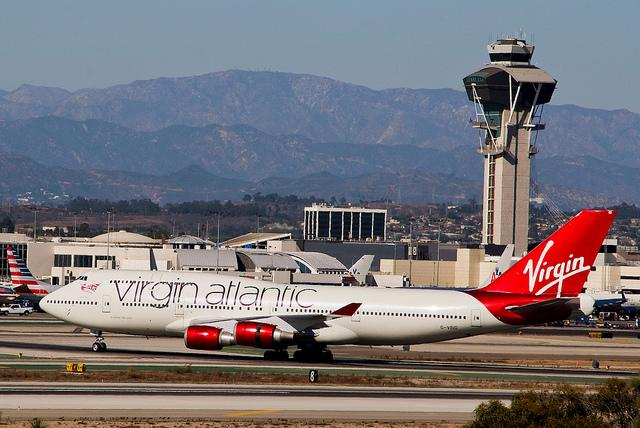What famous billionaire started the Virgin airline company? richard branson 